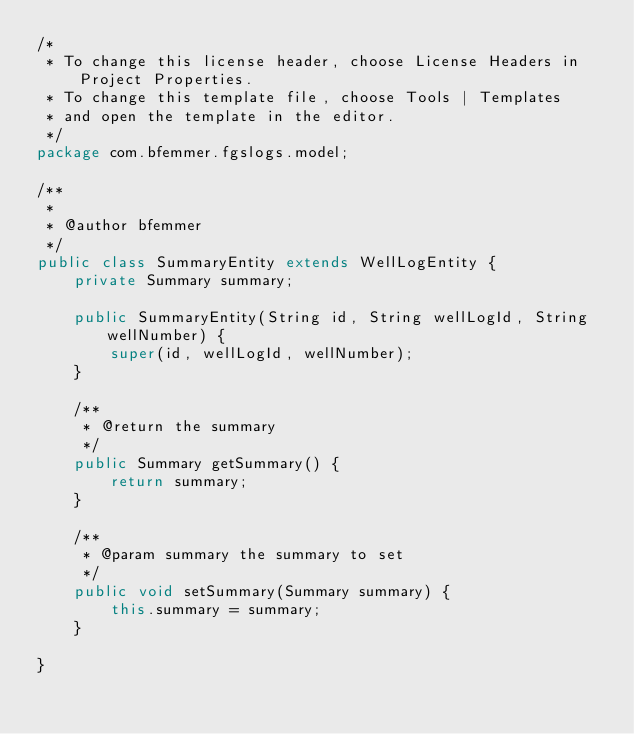<code> <loc_0><loc_0><loc_500><loc_500><_Java_>/*
 * To change this license header, choose License Headers in Project Properties.
 * To change this template file, choose Tools | Templates
 * and open the template in the editor.
 */
package com.bfemmer.fgslogs.model;

/**
 *
 * @author bfemmer
 */
public class SummaryEntity extends WellLogEntity {
    private Summary summary;
    
    public SummaryEntity(String id, String wellLogId, String wellNumber) {
        super(id, wellLogId, wellNumber);
    }

    /**
     * @return the summary
     */
    public Summary getSummary() {
        return summary;
    }

    /**
     * @param summary the summary to set
     */
    public void setSummary(Summary summary) {
        this.summary = summary;
    }
    
}
</code> 